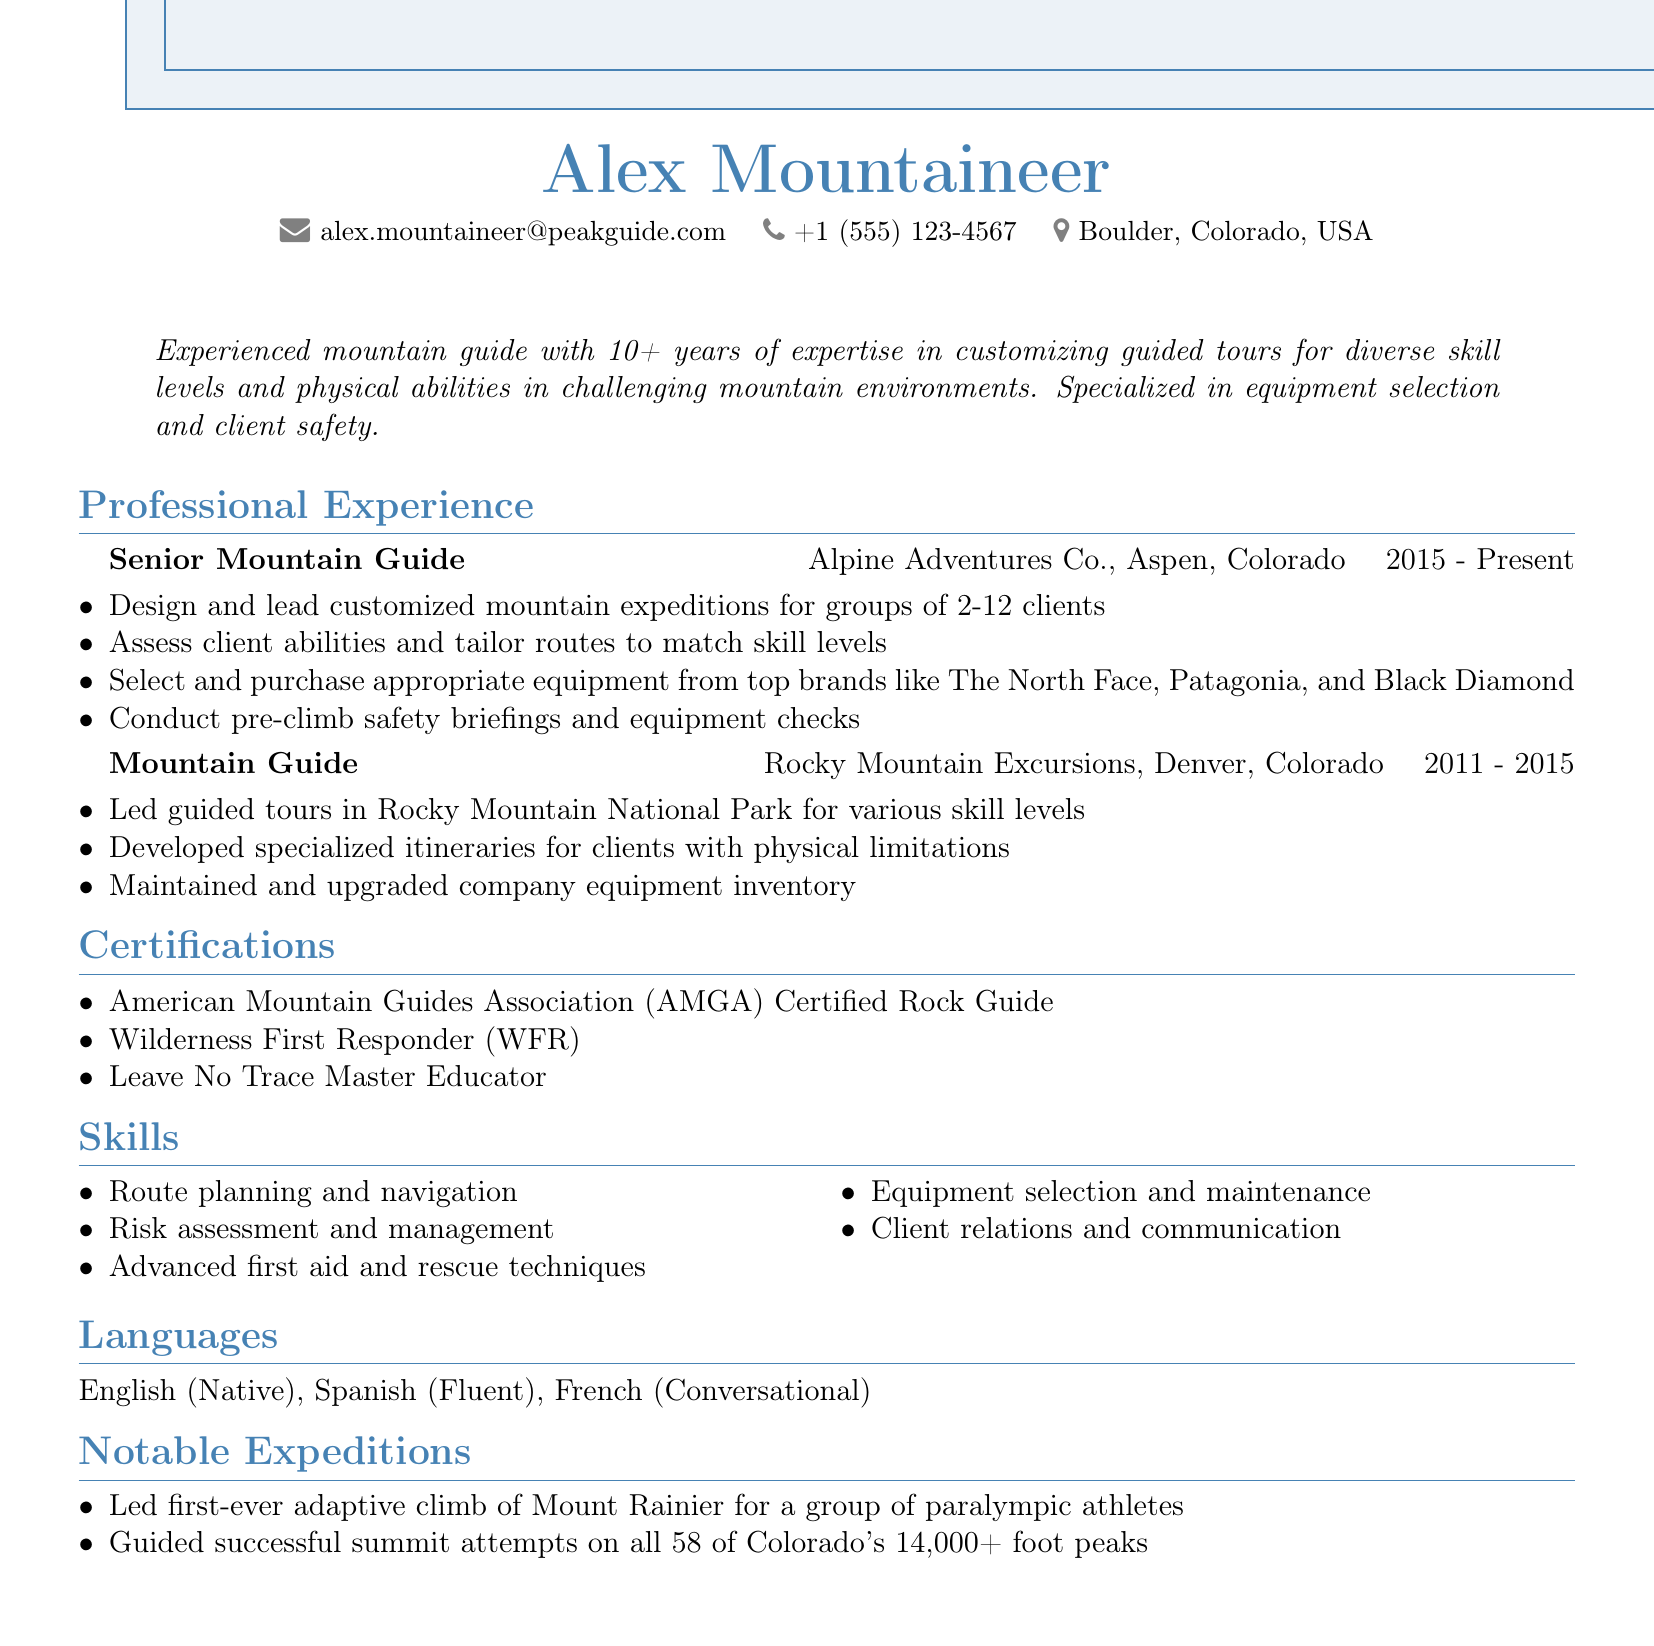What is the name of the mountain guide? The document lists the name of the mountain guide as Alex Mountaineer.
Answer: Alex Mountaineer How many years of experience does the guide have? The summary states that the guide has over 10 years of experience.
Answer: 10+ What is the title of the current position held by the guide? The professional experience section lists the current title as Senior Mountain Guide.
Answer: Senior Mountain Guide Which company does Alex work for currently? The professional experience section specifies that Alex works for Alpine Adventures Co.
Answer: Alpine Adventures Co What notable achievement is mentioned in the expeditions section? The notable expeditions section highlights leading the first-ever adaptive climb of Mount Rainier.
Answer: First-ever adaptive climb of Mount Rainier How many languages can Alex speak? The languages section lists three languages that Alex can speak.
Answer: Three What certification does Alex hold related to wilderness medicine? The certifications section indicates that Alex is a Wilderness First Responder.
Answer: Wilderness First Responder What type of clients did Alex develop itineraries for in previous experience? The responsibilities under Mountain Guide mention developing itineraries for clients with physical limitations.
Answer: Clients with physical limitations What equipment brands does Alex select for clients? The responsibilities under Senior Mountain Guide mention top brands like The North Face, Patagonia, and Black Diamond.
Answer: The North Face, Patagonia, and Black Diamond 